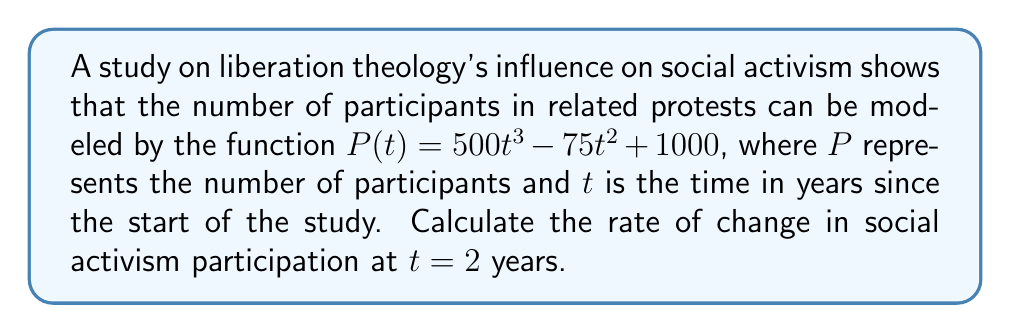What is the answer to this math problem? To find the rate of change in social activism participation at $t = 2$ years, we need to calculate the derivative of the given function $P(t)$ and then evaluate it at $t = 2$.

Step 1: Find the derivative of $P(t)$.
$$P(t) = 500t^3 - 75t^2 + 1000$$
$$P'(t) = 1500t^2 - 150t$$

Step 2: Evaluate $P'(t)$ at $t = 2$.
$$P'(2) = 1500(2)^2 - 150(2)$$
$$P'(2) = 1500(4) - 300$$
$$P'(2) = 6000 - 300$$
$$P'(2) = 5700$$

The rate of change at $t = 2$ years is 5700 participants per year.
Answer: 5700 participants/year 